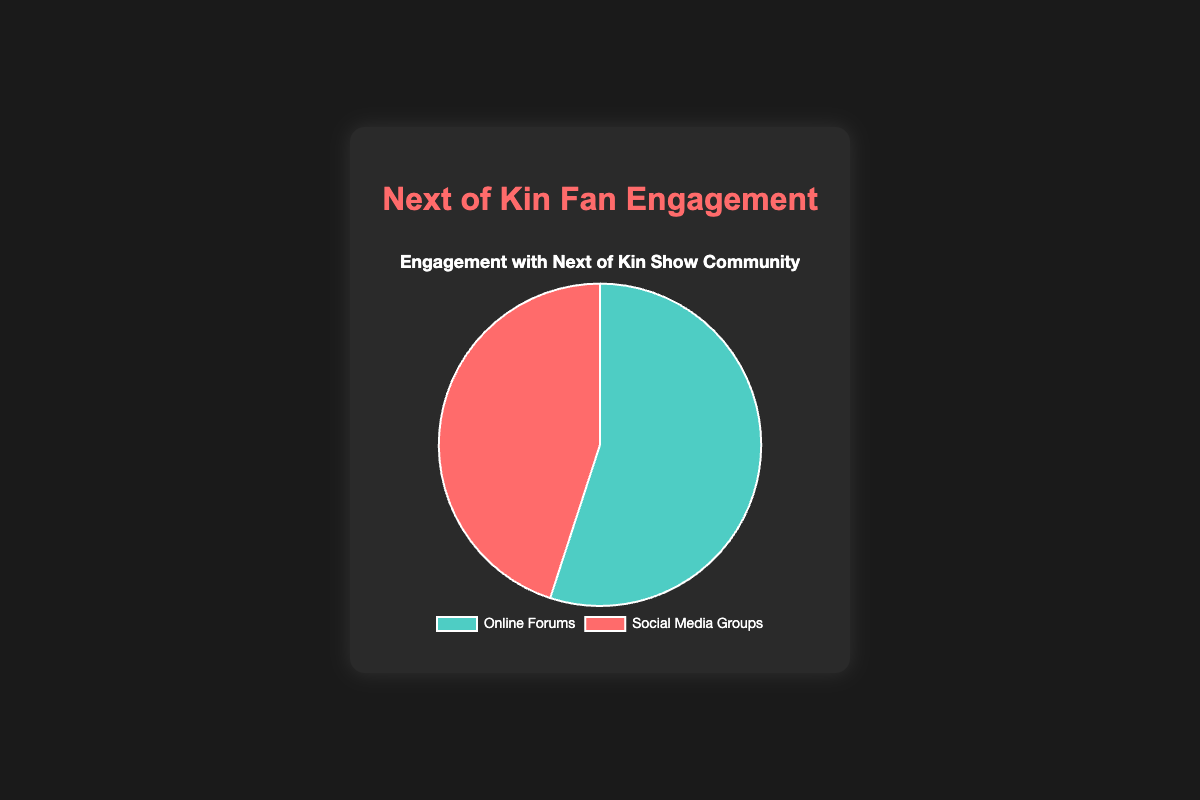What percentage of the Next of Kin community engages in Online Forums? The chart clearly shows that the Online Forums section accounts for 55% of the engagement.
Answer: 55% What percentage of the community engages in Social Media Groups? The chart indicates that 45% of the engagements come from Social Media Groups.
Answer: 45% Which form of engagement has a higher percentage, Online Forums or Social Media Groups? Comparing the two sections, Online Forums have 55% while Social Media Groups have 45%. Therefore, Online Forums have the higher percentage.
Answer: Online Forums What is the difference in engagement percentage between Online Forums and Social Media Groups? The engagement percentage for Online Forums is 55% and for Social Media Groups is 45%. The difference is calculated as 55% - 45%, which equals 10%.
Answer: 10% What proportion of the community engages in either Online Forums or Social Media Groups? The entire community is divided into two categories: Online Forums (55%) and Social Media Groups (45%). Adding these percentages, the total engagement is 55% + 45% = 100%.
Answer: 100% What is the sum of the engagement percentages for both Online Forums and Social Media Groups? Adding the percentages for Online Forums (55%) and Social Media Groups (45%) results in 55% + 45% = 100%.
Answer: 100% If the total community engagement is 1,000 people, how many people engage in Online Forums? To find the number of people engaging in Online Forums, calculate 55% of 1,000. This is done by multiplying 1,000 by 0.55, resulting in 550 people.
Answer: 550 If the total community engagement is 1,000 people, how many engage in Social Media Groups? Calculate 45% of 1,000 to find the number of people engaging in Social Media Groups. Multiply 1,000 by 0.45, which equals 450 people.
Answer: 450 Is the engagement with Online Forums more than half of the total community engagement? The engagement in Online Forums is 55%, which is indeed more than half (50%) of the total community engagement.
Answer: Yes Which segment is represented by the blue color in the pie chart? The blue color in the pie chart represents the Online Forums segment, as indicated by the chart’s key.
Answer: Online Forums 